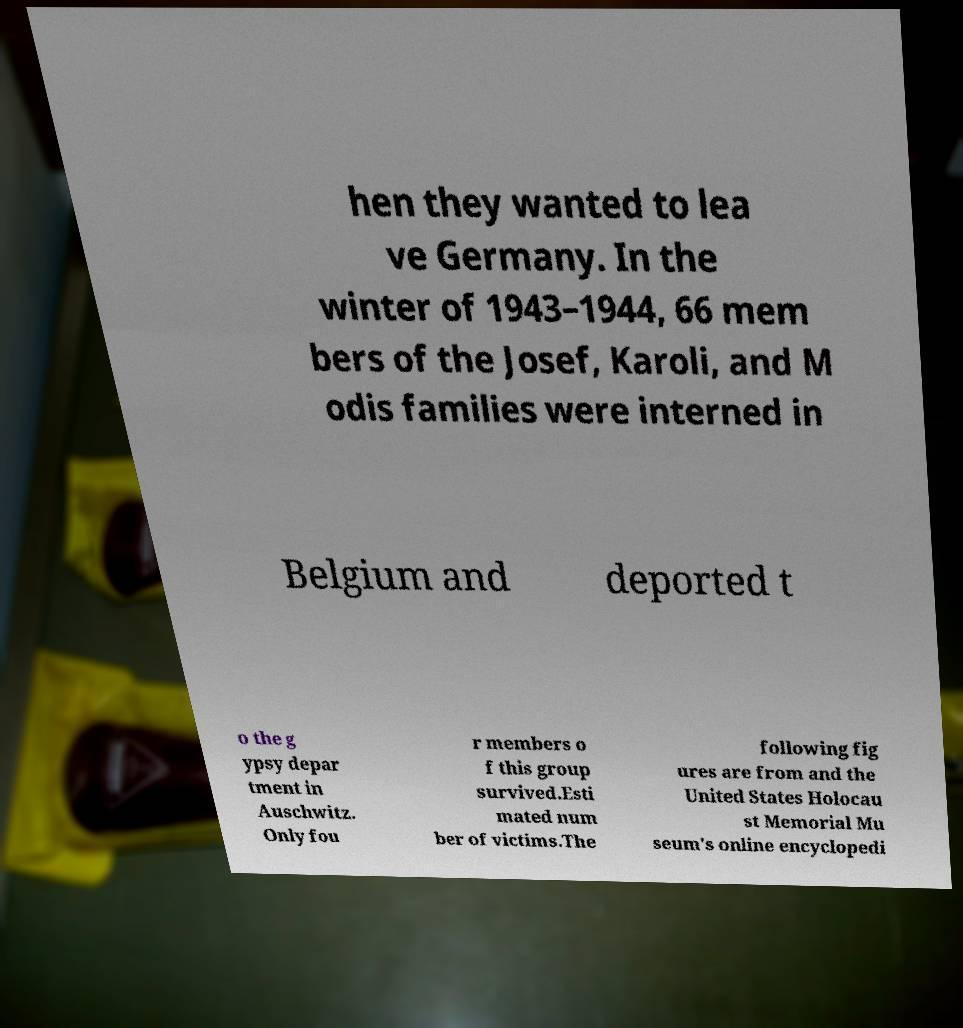I need the written content from this picture converted into text. Can you do that? hen they wanted to lea ve Germany. In the winter of 1943–1944, 66 mem bers of the Josef, Karoli, and M odis families were interned in Belgium and deported t o the g ypsy depar tment in Auschwitz. Only fou r members o f this group survived.Esti mated num ber of victims.The following fig ures are from and the United States Holocau st Memorial Mu seum's online encyclopedi 